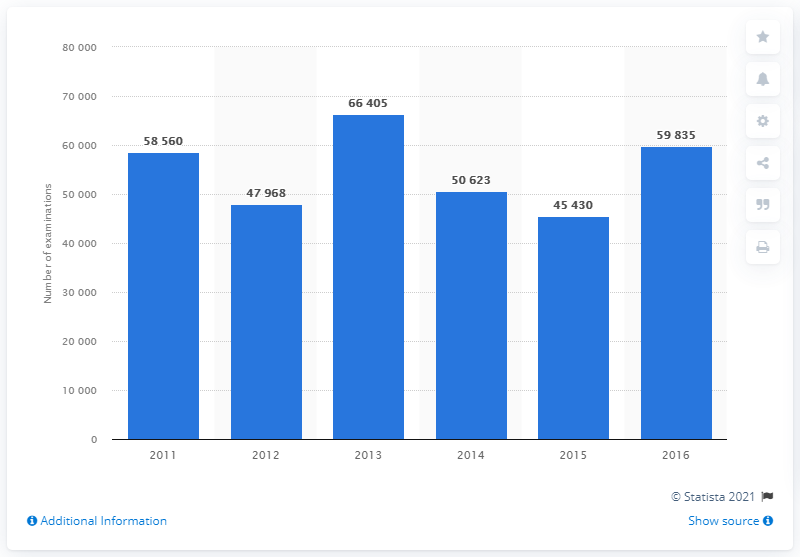Draw attention to some important aspects in this diagram. In 2016, a total of 59,835 MRI scan examinations were conducted in Bulgaria. 